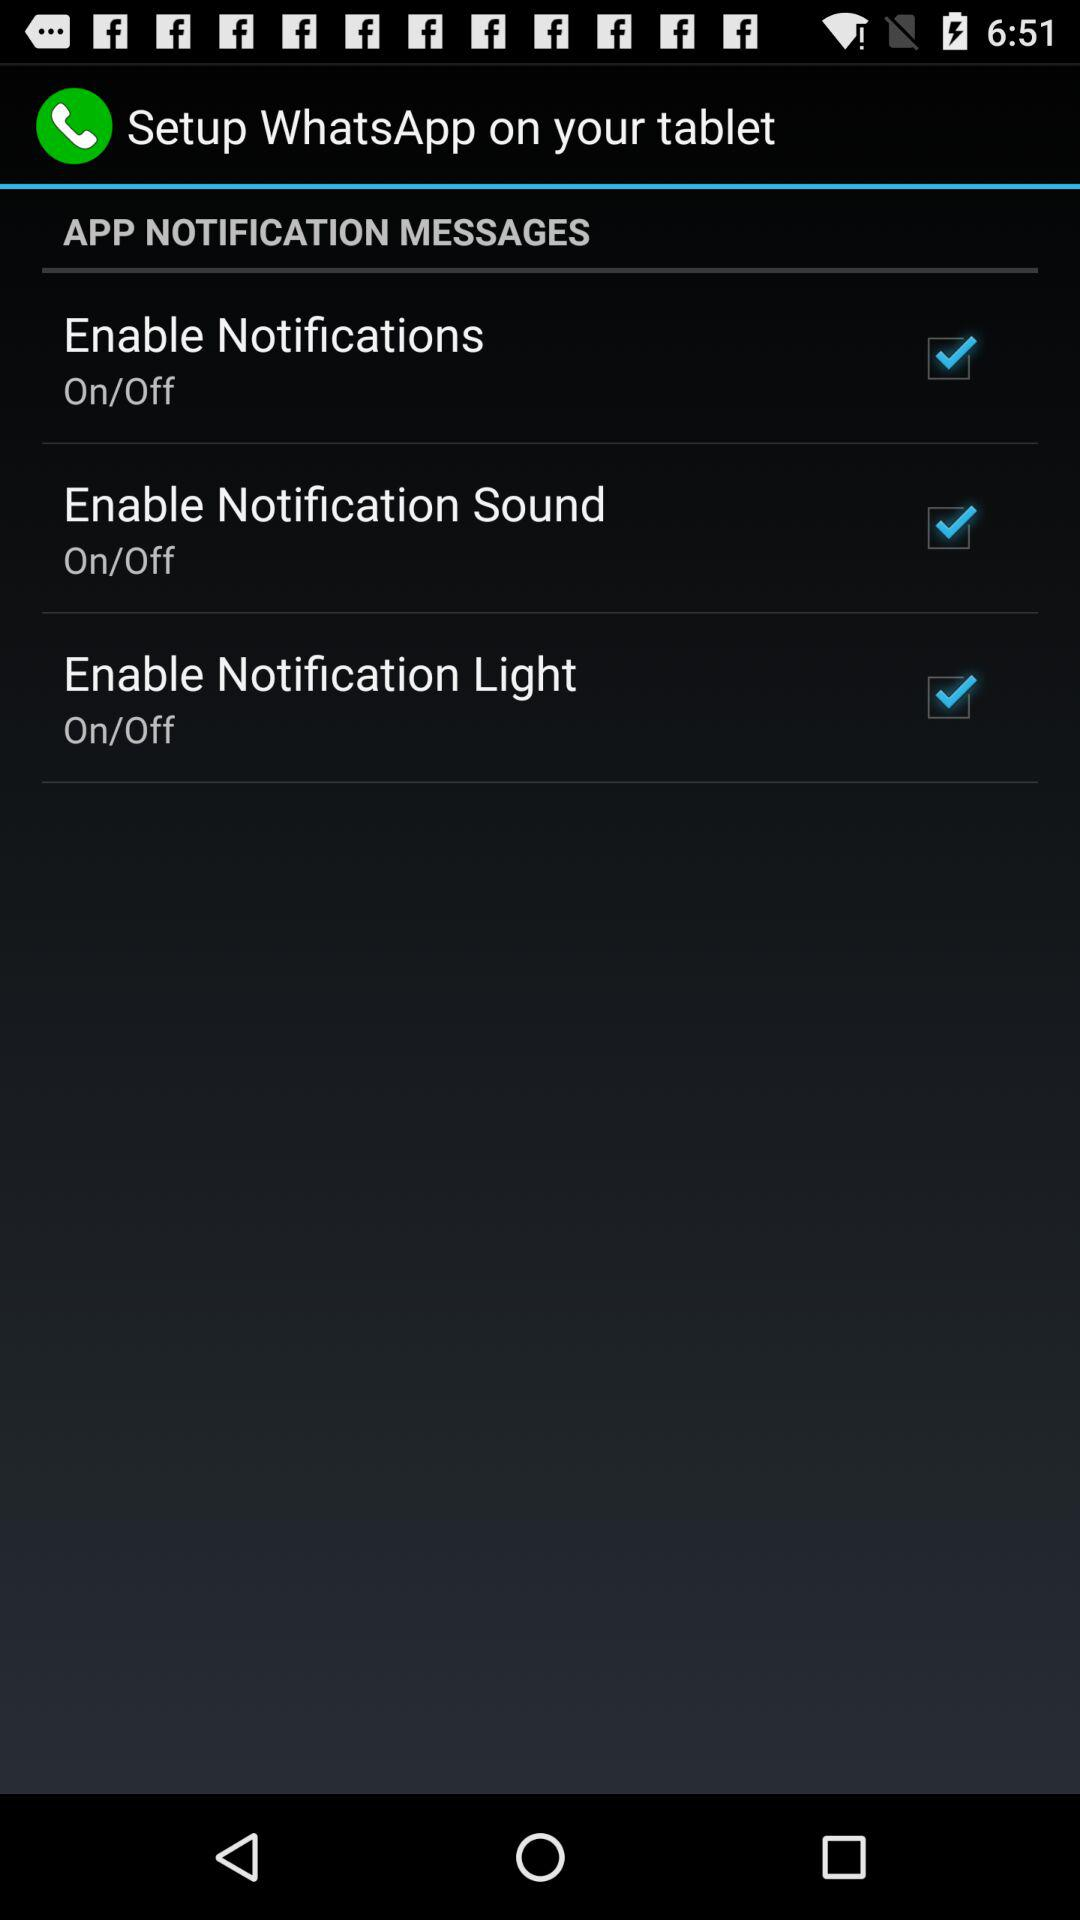What is the status of enable notifications? The status is on. 